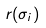Convert formula to latex. <formula><loc_0><loc_0><loc_500><loc_500>r ( \sigma _ { i } )</formula> 